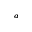Convert formula to latex. <formula><loc_0><loc_0><loc_500><loc_500>^ { a }</formula> 